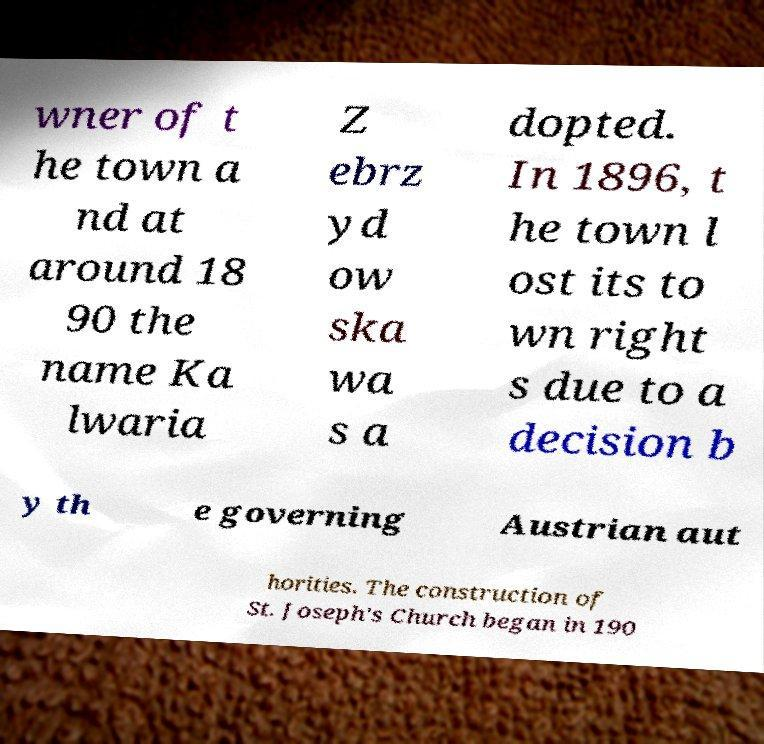What messages or text are displayed in this image? I need them in a readable, typed format. wner of t he town a nd at around 18 90 the name Ka lwaria Z ebrz yd ow ska wa s a dopted. In 1896, t he town l ost its to wn right s due to a decision b y th e governing Austrian aut horities. The construction of St. Joseph's Church began in 190 